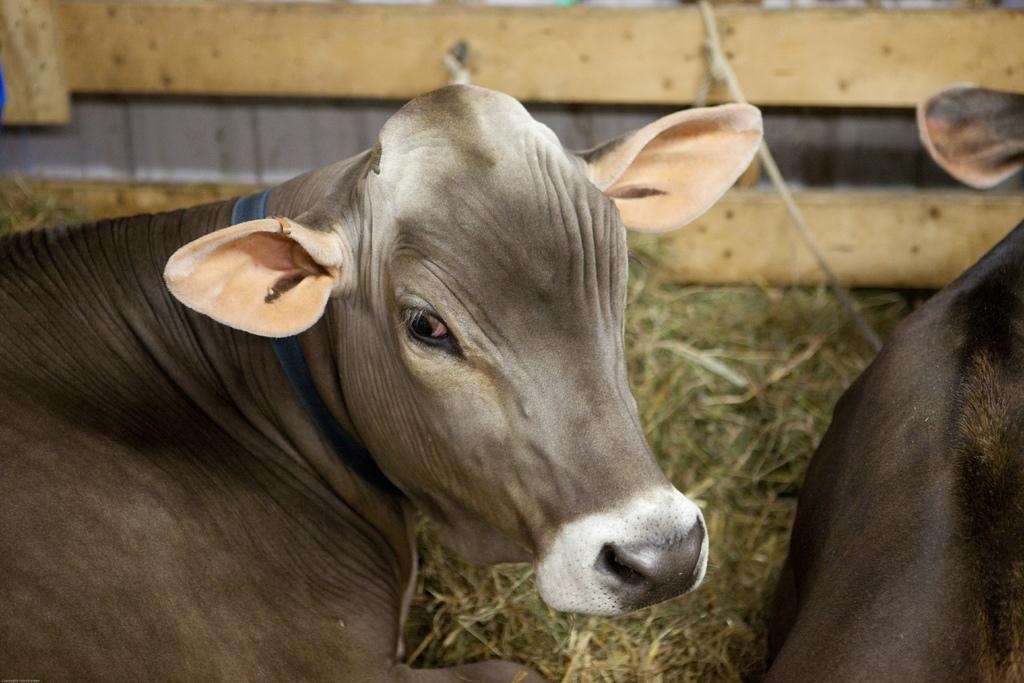What animals are sitting on the ground in the image? There are cows sitting on the ground in the image. What type of vegetation is on the ground in the image? There is grass on the ground in the image. What can be seen in the background of the image? There is a wooden wall in the background of the image. What is attached to the wooden wall in the image? There is a rope attached to the wooden wall in the image. What type of car is visible in the image? There is no car present in the image. Is there any smoke coming from the cows in the image? No, there is no smoke coming from the cows in the image. 